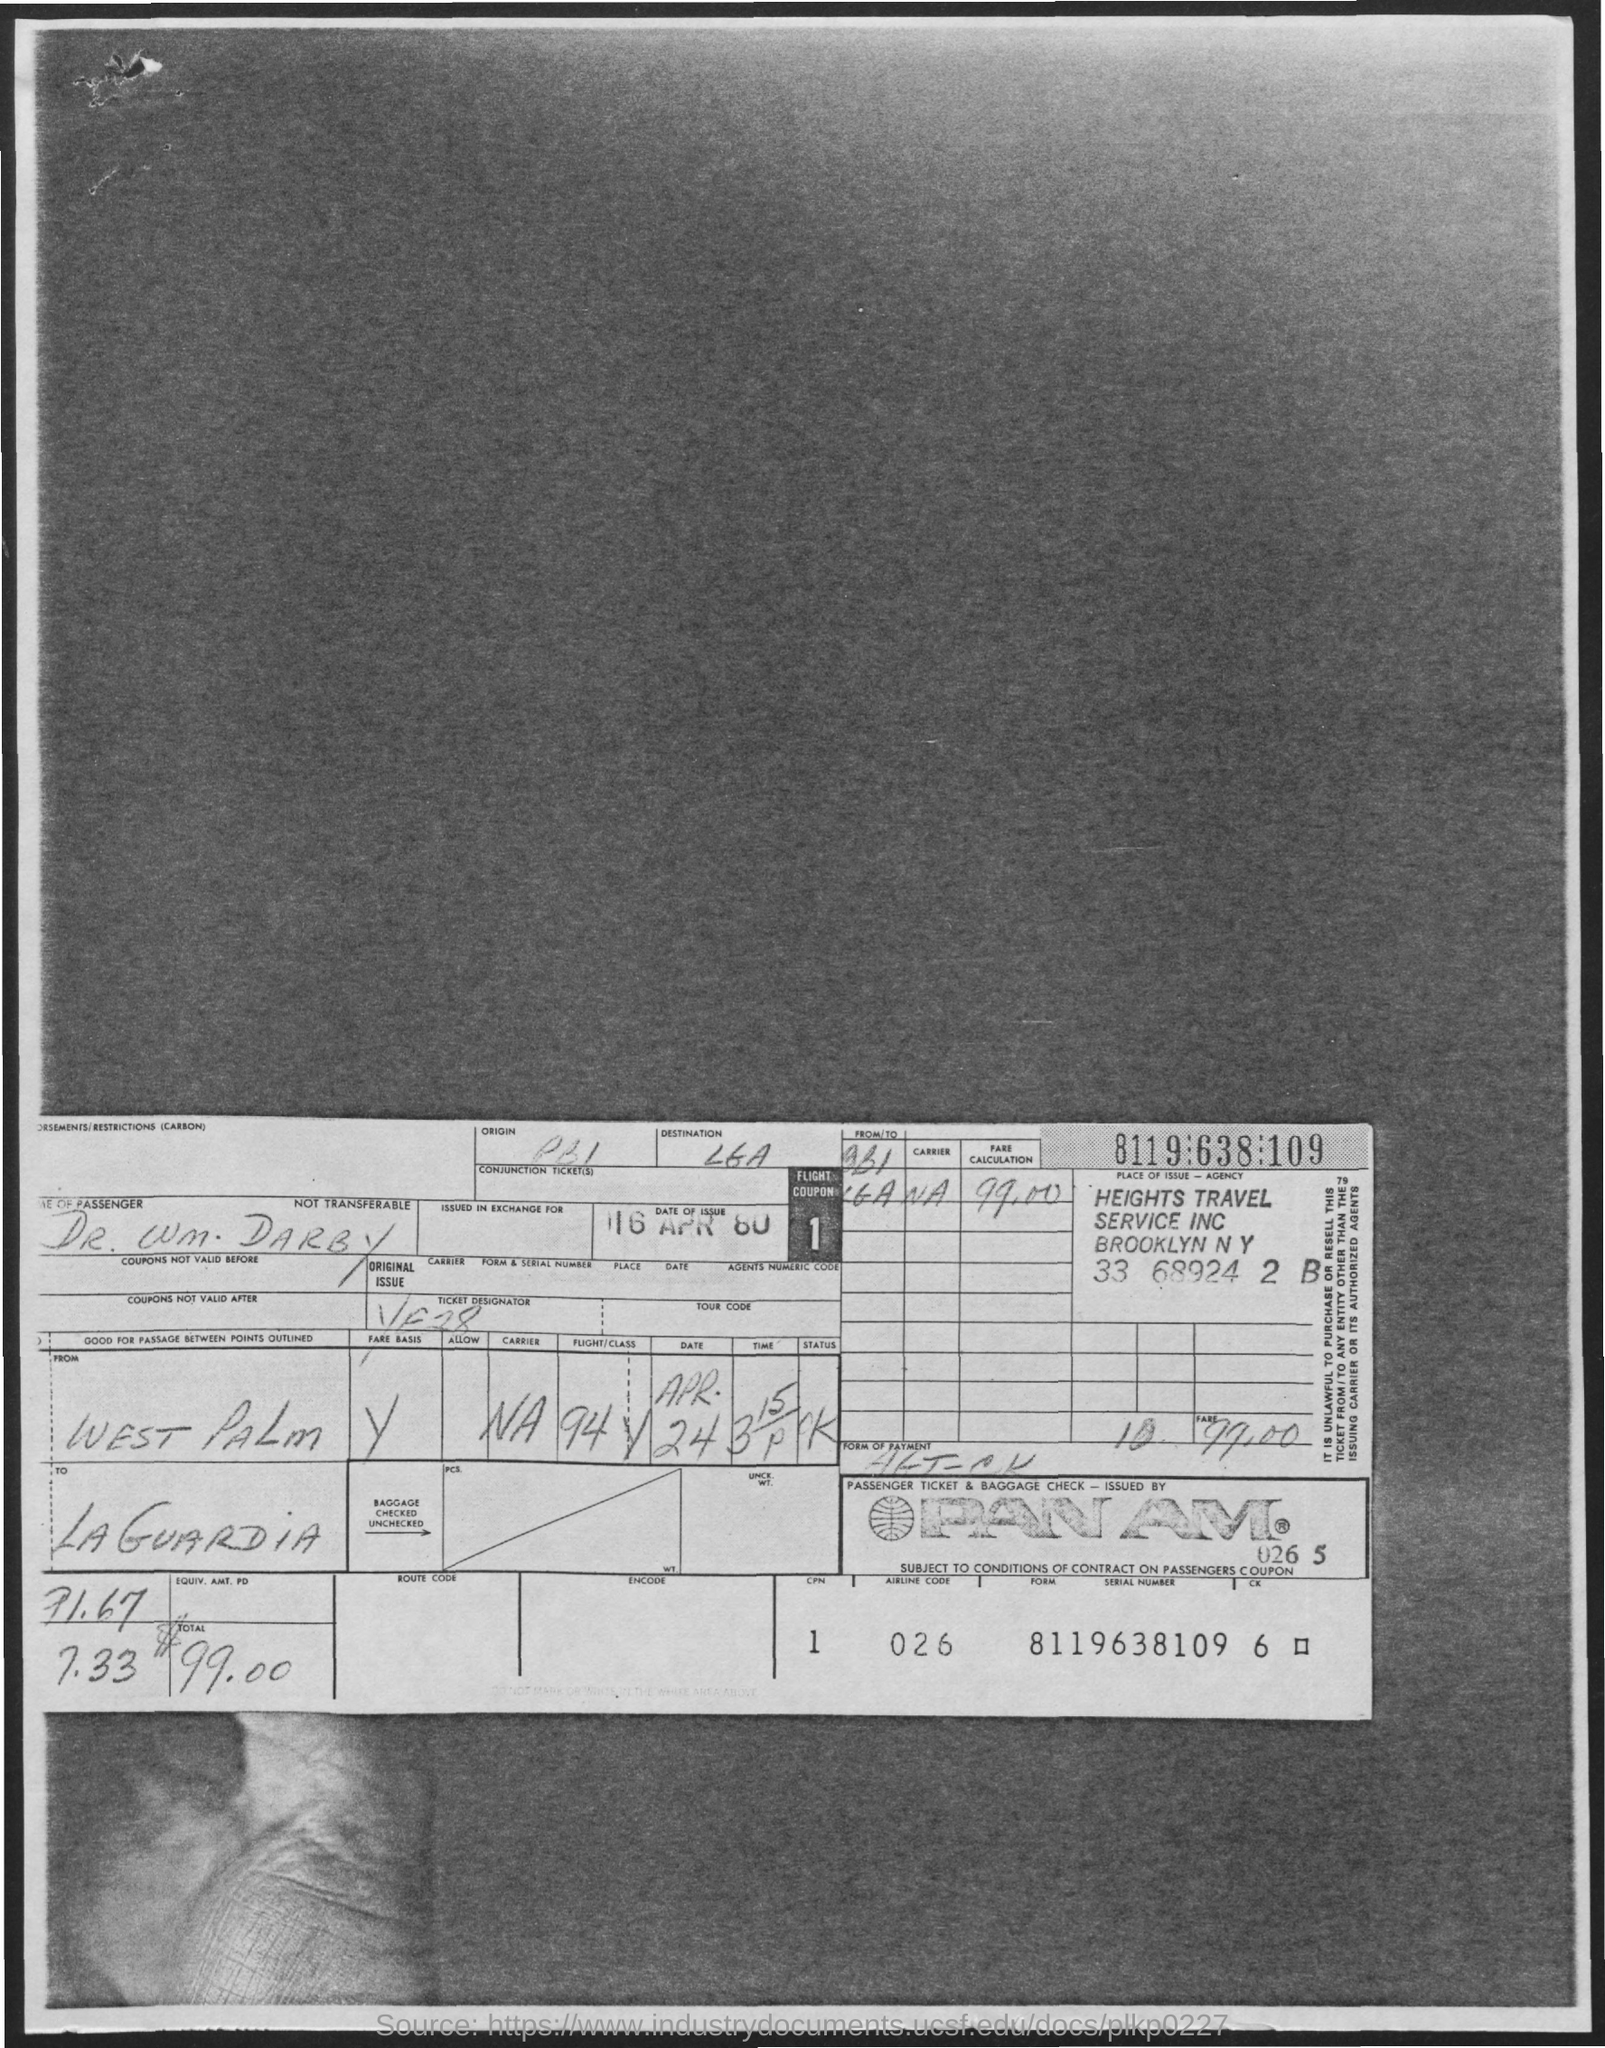What is the name of the passenger?
Give a very brief answer. Dr. WM. Darby. What is the date of issue?
Keep it short and to the point. 16 APR 80. What is the airline code?
Your answer should be compact. 026. Passenger ticket & baggage check- issued by ?
Your response must be concise. PAN AM. What is the form serial number?
Provide a succinct answer. 8119638109. What is the name of the departure station?
Keep it short and to the point. West Palm. What is the name of the arrival station?
Offer a very short reply. LaGuardia. What is the total amount ?
Ensure brevity in your answer.  $99.00. 